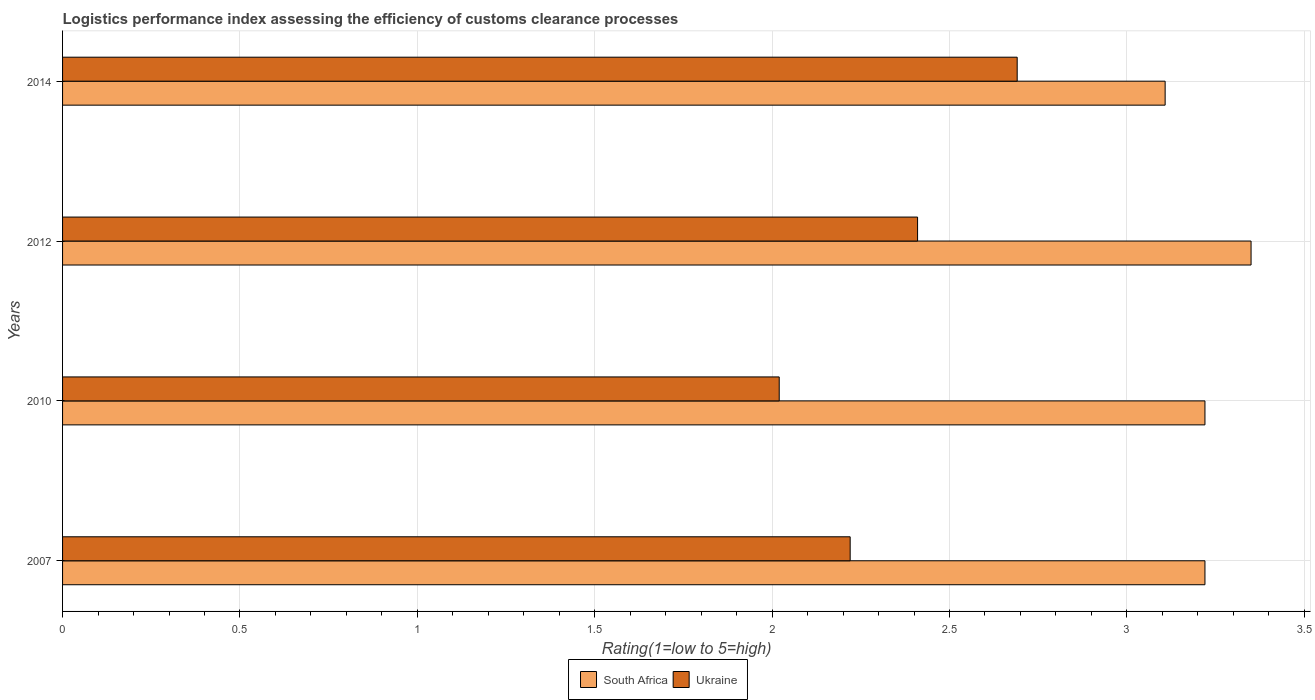How many groups of bars are there?
Your answer should be compact. 4. Are the number of bars on each tick of the Y-axis equal?
Your answer should be compact. Yes. How many bars are there on the 3rd tick from the top?
Offer a terse response. 2. How many bars are there on the 3rd tick from the bottom?
Keep it short and to the point. 2. What is the label of the 4th group of bars from the top?
Offer a terse response. 2007. In how many cases, is the number of bars for a given year not equal to the number of legend labels?
Keep it short and to the point. 0. What is the Logistic performance index in Ukraine in 2010?
Offer a very short reply. 2.02. Across all years, what is the maximum Logistic performance index in Ukraine?
Provide a short and direct response. 2.69. Across all years, what is the minimum Logistic performance index in South Africa?
Make the answer very short. 3.11. What is the total Logistic performance index in Ukraine in the graph?
Your answer should be compact. 9.34. What is the difference between the Logistic performance index in Ukraine in 2010 and that in 2012?
Your answer should be very brief. -0.39. What is the difference between the Logistic performance index in Ukraine in 2014 and the Logistic performance index in South Africa in 2007?
Provide a succinct answer. -0.53. What is the average Logistic performance index in South Africa per year?
Offer a very short reply. 3.22. In the year 2014, what is the difference between the Logistic performance index in Ukraine and Logistic performance index in South Africa?
Offer a terse response. -0.42. In how many years, is the Logistic performance index in Ukraine greater than 0.4 ?
Give a very brief answer. 4. Is the difference between the Logistic performance index in Ukraine in 2007 and 2012 greater than the difference between the Logistic performance index in South Africa in 2007 and 2012?
Offer a terse response. No. What is the difference between the highest and the second highest Logistic performance index in South Africa?
Keep it short and to the point. 0.13. What is the difference between the highest and the lowest Logistic performance index in South Africa?
Offer a very short reply. 0.24. In how many years, is the Logistic performance index in South Africa greater than the average Logistic performance index in South Africa taken over all years?
Make the answer very short. 1. What does the 2nd bar from the top in 2007 represents?
Provide a succinct answer. South Africa. What does the 2nd bar from the bottom in 2012 represents?
Offer a terse response. Ukraine. Does the graph contain grids?
Ensure brevity in your answer.  Yes. Where does the legend appear in the graph?
Provide a short and direct response. Bottom center. How many legend labels are there?
Your answer should be compact. 2. What is the title of the graph?
Ensure brevity in your answer.  Logistics performance index assessing the efficiency of customs clearance processes. What is the label or title of the X-axis?
Offer a very short reply. Rating(1=low to 5=high). What is the label or title of the Y-axis?
Make the answer very short. Years. What is the Rating(1=low to 5=high) in South Africa in 2007?
Your response must be concise. 3.22. What is the Rating(1=low to 5=high) in Ukraine in 2007?
Provide a succinct answer. 2.22. What is the Rating(1=low to 5=high) of South Africa in 2010?
Provide a short and direct response. 3.22. What is the Rating(1=low to 5=high) in Ukraine in 2010?
Ensure brevity in your answer.  2.02. What is the Rating(1=low to 5=high) of South Africa in 2012?
Offer a terse response. 3.35. What is the Rating(1=low to 5=high) in Ukraine in 2012?
Make the answer very short. 2.41. What is the Rating(1=low to 5=high) of South Africa in 2014?
Offer a terse response. 3.11. What is the Rating(1=low to 5=high) of Ukraine in 2014?
Ensure brevity in your answer.  2.69. Across all years, what is the maximum Rating(1=low to 5=high) of South Africa?
Give a very brief answer. 3.35. Across all years, what is the maximum Rating(1=low to 5=high) of Ukraine?
Provide a succinct answer. 2.69. Across all years, what is the minimum Rating(1=low to 5=high) in South Africa?
Your answer should be compact. 3.11. Across all years, what is the minimum Rating(1=low to 5=high) in Ukraine?
Your answer should be very brief. 2.02. What is the total Rating(1=low to 5=high) of South Africa in the graph?
Your answer should be very brief. 12.9. What is the total Rating(1=low to 5=high) of Ukraine in the graph?
Provide a short and direct response. 9.34. What is the difference between the Rating(1=low to 5=high) of South Africa in 2007 and that in 2010?
Make the answer very short. 0. What is the difference between the Rating(1=low to 5=high) in South Africa in 2007 and that in 2012?
Provide a succinct answer. -0.13. What is the difference between the Rating(1=low to 5=high) in Ukraine in 2007 and that in 2012?
Keep it short and to the point. -0.19. What is the difference between the Rating(1=low to 5=high) of South Africa in 2007 and that in 2014?
Provide a short and direct response. 0.11. What is the difference between the Rating(1=low to 5=high) of Ukraine in 2007 and that in 2014?
Your answer should be very brief. -0.47. What is the difference between the Rating(1=low to 5=high) of South Africa in 2010 and that in 2012?
Your response must be concise. -0.13. What is the difference between the Rating(1=low to 5=high) of Ukraine in 2010 and that in 2012?
Provide a succinct answer. -0.39. What is the difference between the Rating(1=low to 5=high) in South Africa in 2010 and that in 2014?
Provide a short and direct response. 0.11. What is the difference between the Rating(1=low to 5=high) of Ukraine in 2010 and that in 2014?
Make the answer very short. -0.67. What is the difference between the Rating(1=low to 5=high) in South Africa in 2012 and that in 2014?
Your response must be concise. 0.24. What is the difference between the Rating(1=low to 5=high) in Ukraine in 2012 and that in 2014?
Ensure brevity in your answer.  -0.28. What is the difference between the Rating(1=low to 5=high) in South Africa in 2007 and the Rating(1=low to 5=high) in Ukraine in 2012?
Give a very brief answer. 0.81. What is the difference between the Rating(1=low to 5=high) of South Africa in 2007 and the Rating(1=low to 5=high) of Ukraine in 2014?
Provide a short and direct response. 0.53. What is the difference between the Rating(1=low to 5=high) of South Africa in 2010 and the Rating(1=low to 5=high) of Ukraine in 2012?
Your answer should be very brief. 0.81. What is the difference between the Rating(1=low to 5=high) in South Africa in 2010 and the Rating(1=low to 5=high) in Ukraine in 2014?
Give a very brief answer. 0.53. What is the difference between the Rating(1=low to 5=high) of South Africa in 2012 and the Rating(1=low to 5=high) of Ukraine in 2014?
Offer a terse response. 0.66. What is the average Rating(1=low to 5=high) of South Africa per year?
Your response must be concise. 3.22. What is the average Rating(1=low to 5=high) of Ukraine per year?
Keep it short and to the point. 2.34. In the year 2007, what is the difference between the Rating(1=low to 5=high) of South Africa and Rating(1=low to 5=high) of Ukraine?
Give a very brief answer. 1. In the year 2012, what is the difference between the Rating(1=low to 5=high) in South Africa and Rating(1=low to 5=high) in Ukraine?
Provide a short and direct response. 0.94. In the year 2014, what is the difference between the Rating(1=low to 5=high) in South Africa and Rating(1=low to 5=high) in Ukraine?
Give a very brief answer. 0.42. What is the ratio of the Rating(1=low to 5=high) in South Africa in 2007 to that in 2010?
Offer a very short reply. 1. What is the ratio of the Rating(1=low to 5=high) of Ukraine in 2007 to that in 2010?
Your response must be concise. 1.1. What is the ratio of the Rating(1=low to 5=high) of South Africa in 2007 to that in 2012?
Your answer should be very brief. 0.96. What is the ratio of the Rating(1=low to 5=high) in Ukraine in 2007 to that in 2012?
Your answer should be very brief. 0.92. What is the ratio of the Rating(1=low to 5=high) of South Africa in 2007 to that in 2014?
Make the answer very short. 1.04. What is the ratio of the Rating(1=low to 5=high) in Ukraine in 2007 to that in 2014?
Your response must be concise. 0.82. What is the ratio of the Rating(1=low to 5=high) in South Africa in 2010 to that in 2012?
Offer a very short reply. 0.96. What is the ratio of the Rating(1=low to 5=high) of Ukraine in 2010 to that in 2012?
Keep it short and to the point. 0.84. What is the ratio of the Rating(1=low to 5=high) in South Africa in 2010 to that in 2014?
Your answer should be very brief. 1.04. What is the ratio of the Rating(1=low to 5=high) in Ukraine in 2010 to that in 2014?
Give a very brief answer. 0.75. What is the ratio of the Rating(1=low to 5=high) in South Africa in 2012 to that in 2014?
Offer a terse response. 1.08. What is the ratio of the Rating(1=low to 5=high) of Ukraine in 2012 to that in 2014?
Ensure brevity in your answer.  0.9. What is the difference between the highest and the second highest Rating(1=low to 5=high) of South Africa?
Keep it short and to the point. 0.13. What is the difference between the highest and the second highest Rating(1=low to 5=high) in Ukraine?
Make the answer very short. 0.28. What is the difference between the highest and the lowest Rating(1=low to 5=high) of South Africa?
Keep it short and to the point. 0.24. What is the difference between the highest and the lowest Rating(1=low to 5=high) in Ukraine?
Offer a terse response. 0.67. 